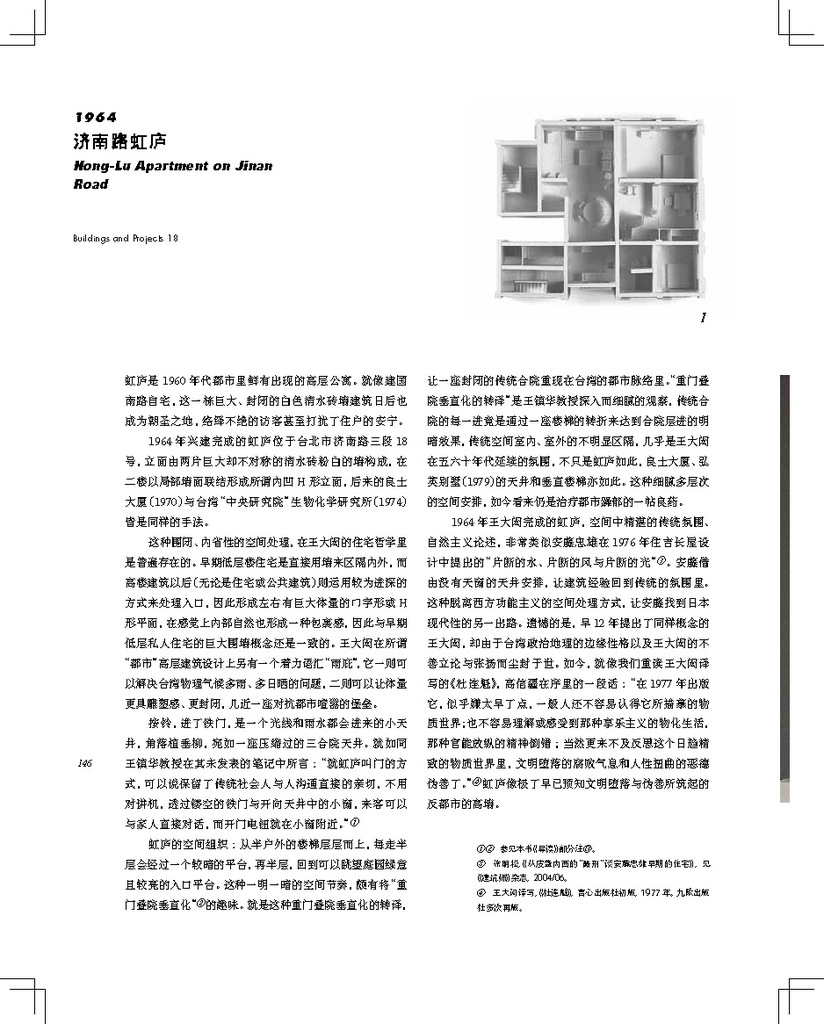Can you describe what architectural features are visible in the floor plan? The floor plan shows a symmetrical layout with multiple rooms arranged around a central living space, indicative of thoughtful spatial efficiency. It includes clearly marked living areas, bedrooms, a kitchen, and bathroom facilities. 